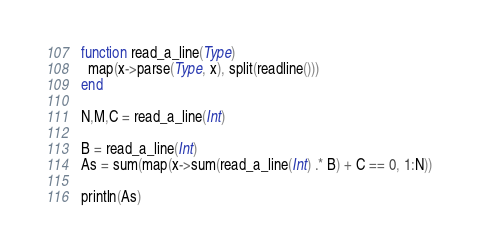<code> <loc_0><loc_0><loc_500><loc_500><_Julia_>function read_a_line(Type)
  map(x->parse(Type, x), split(readline()))
end

N,M,C = read_a_line(Int)

B = read_a_line(Int)
As = sum(map(x->sum(read_a_line(Int) .* B) + C == 0, 1:N))

println(As)</code> 